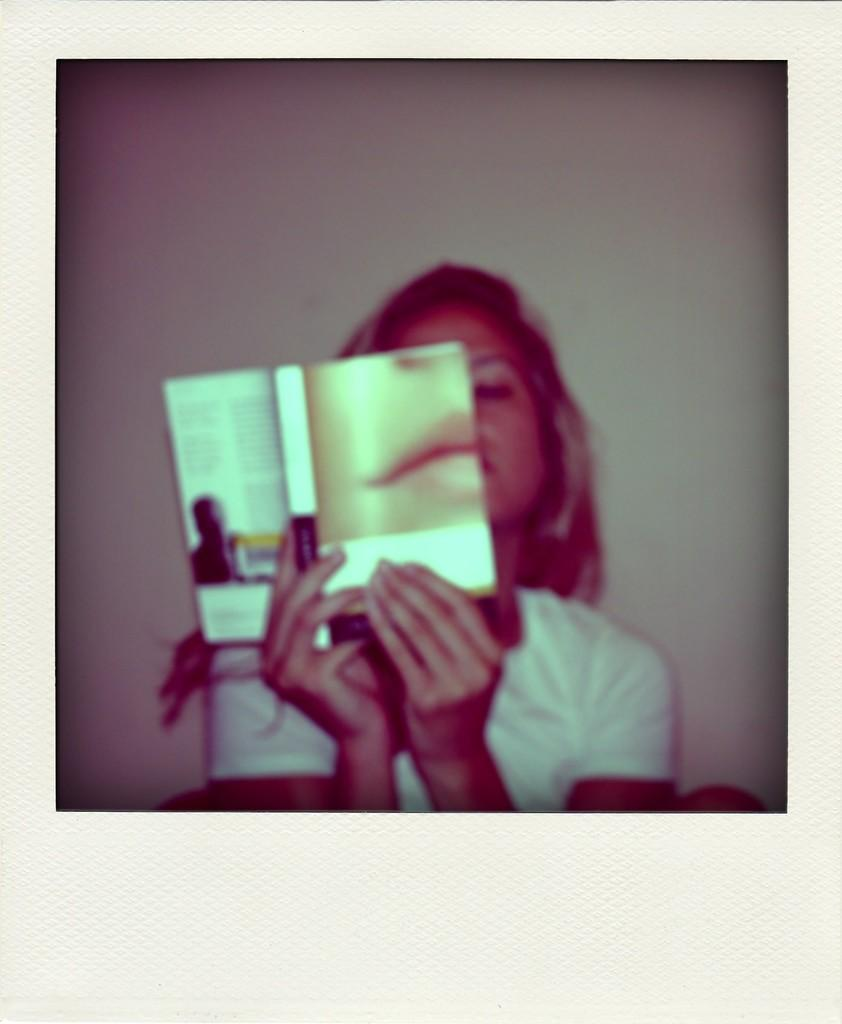Who is the main subject in the image? There is a girl in the image. What is the girl doing in the image? The girl is sitting in the image. What is the girl holding in her hands? The girl is holding a book with her hands. What type of vest is the beast wearing in the image? There is no beast or vest present in the image; it features a girl sitting and holding a book. 